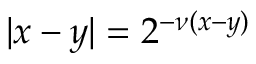<formula> <loc_0><loc_0><loc_500><loc_500>| x - y | = 2 ^ { - \nu ( x - y ) }</formula> 